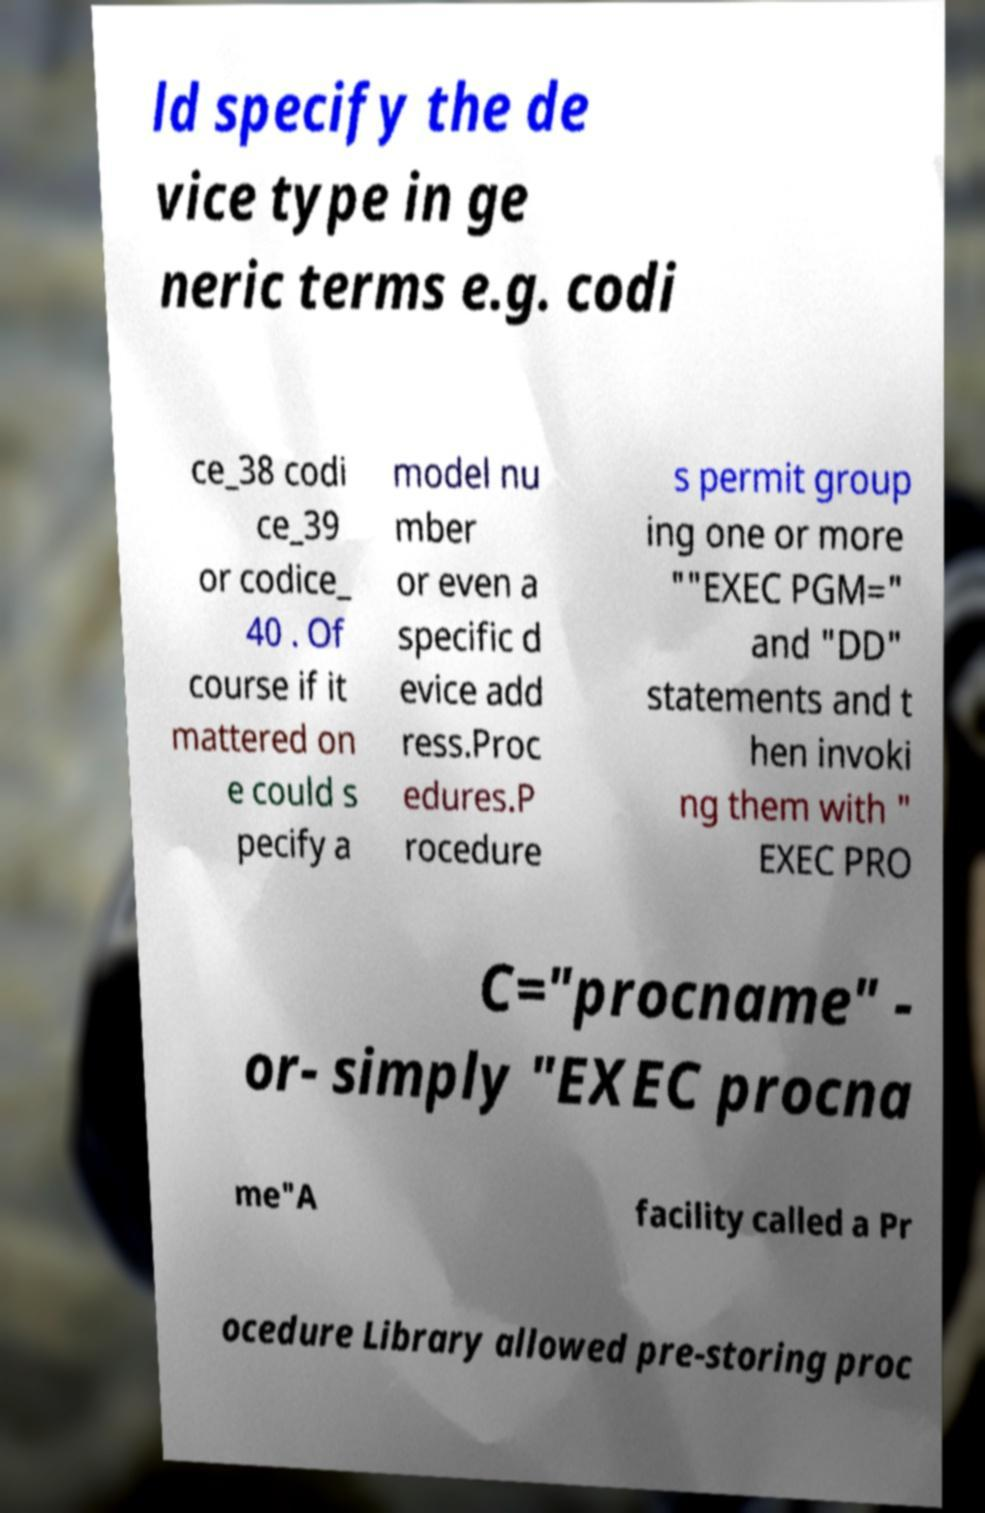Could you assist in decoding the text presented in this image and type it out clearly? ld specify the de vice type in ge neric terms e.g. codi ce_38 codi ce_39 or codice_ 40 . Of course if it mattered on e could s pecify a model nu mber or even a specific d evice add ress.Proc edures.P rocedure s permit group ing one or more ""EXEC PGM=" and "DD" statements and t hen invoki ng them with " EXEC PRO C="procname" - or- simply "EXEC procna me"A facility called a Pr ocedure Library allowed pre-storing proc 